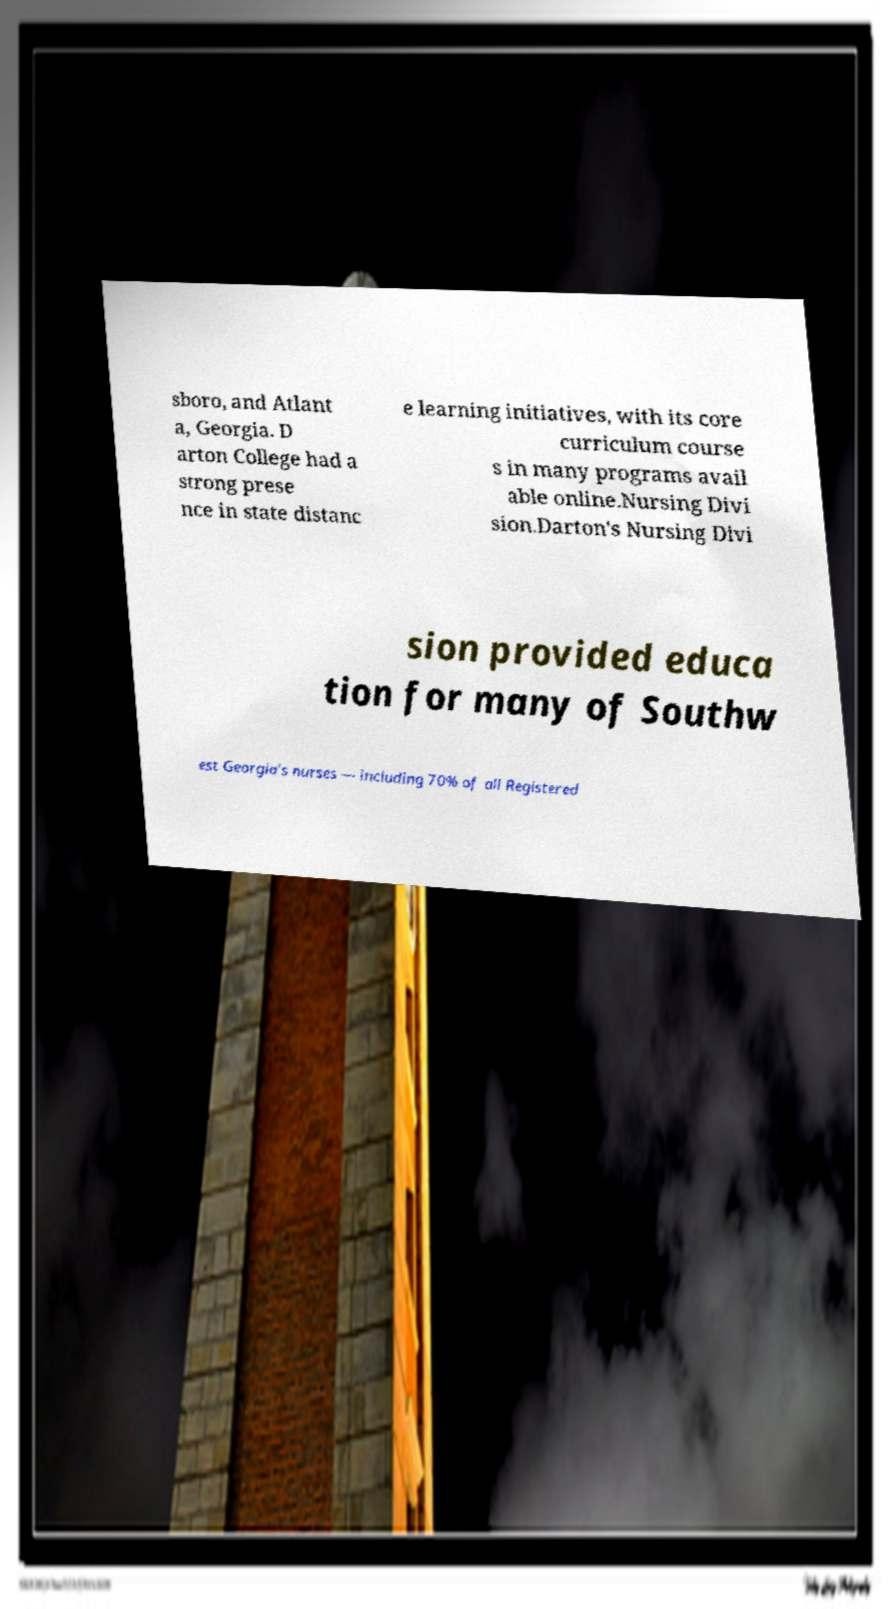Could you extract and type out the text from this image? sboro, and Atlant a, Georgia. D arton College had a strong prese nce in state distanc e learning initiatives, with its core curriculum course s in many programs avail able online.Nursing Divi sion.Darton's Nursing Divi sion provided educa tion for many of Southw est Georgia's nurses — including 70% of all Registered 